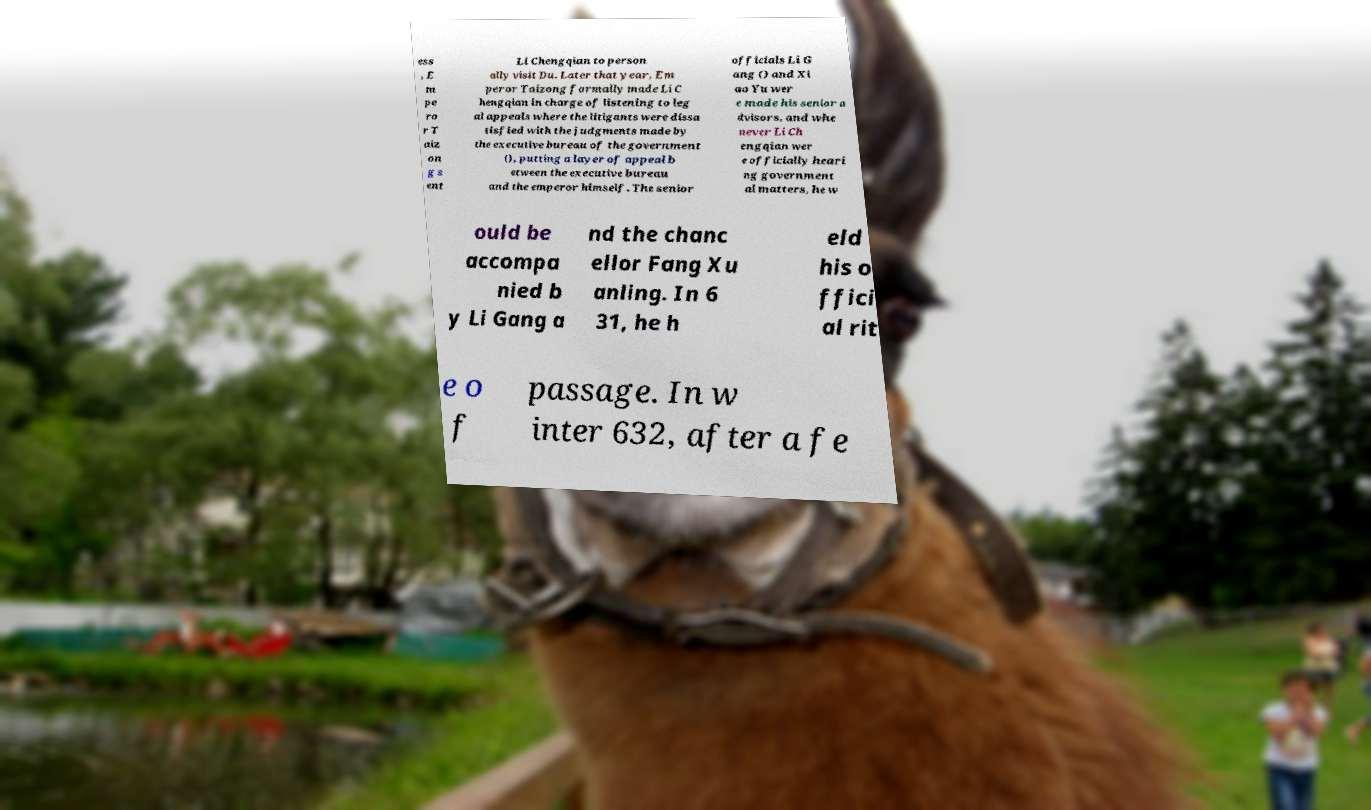Can you read and provide the text displayed in the image?This photo seems to have some interesting text. Can you extract and type it out for me? ess , E m pe ro r T aiz on g s ent Li Chengqian to person ally visit Du. Later that year, Em peror Taizong formally made Li C hengqian in charge of listening to leg al appeals where the litigants were dissa tisfied with the judgments made by the executive bureau of the government (), putting a layer of appeal b etween the executive bureau and the emperor himself. The senior officials Li G ang () and Xi ao Yu wer e made his senior a dvisors, and whe never Li Ch engqian wer e officially heari ng government al matters, he w ould be accompa nied b y Li Gang a nd the chanc ellor Fang Xu anling. In 6 31, he h eld his o ffici al rit e o f passage. In w inter 632, after a fe 